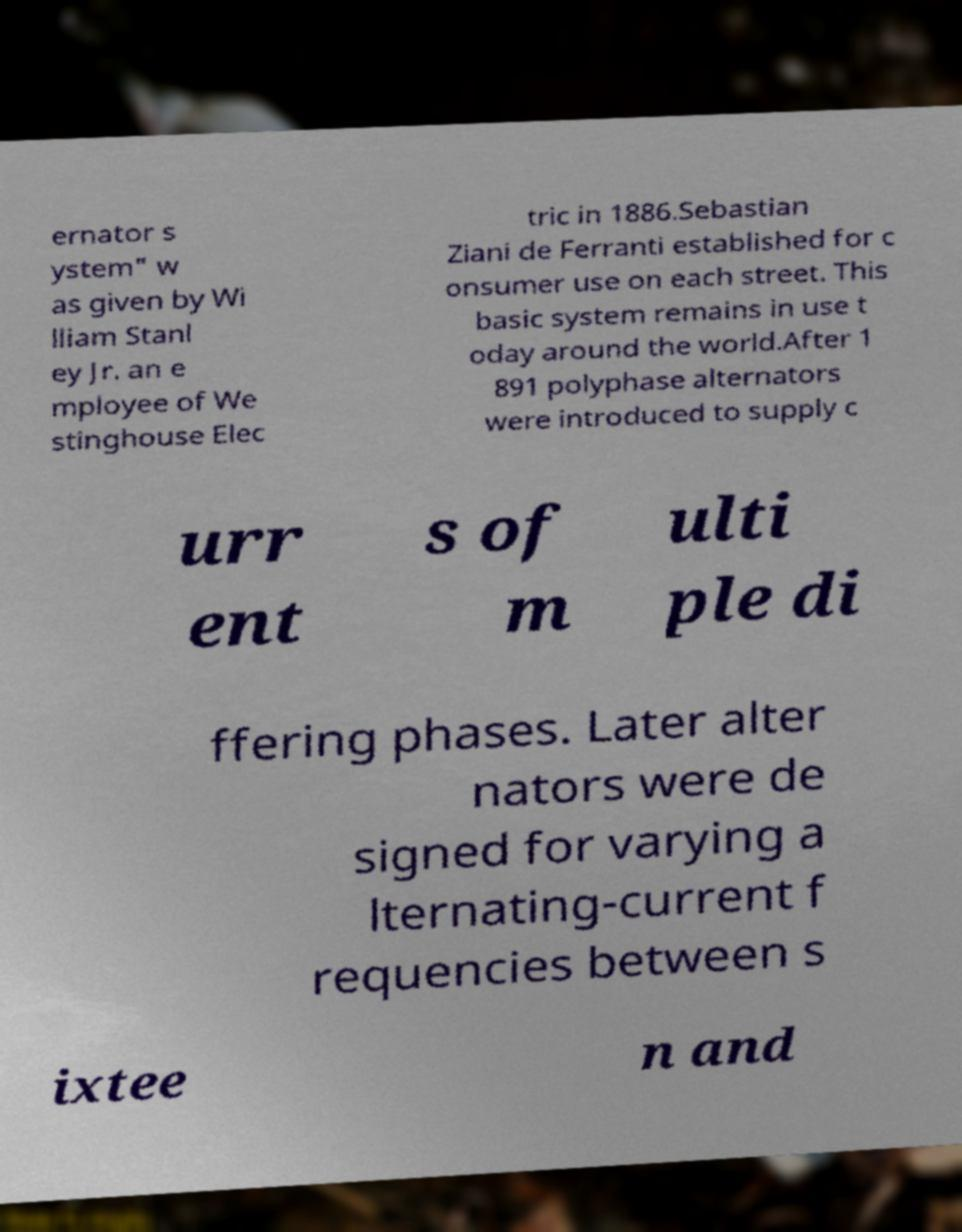Could you assist in decoding the text presented in this image and type it out clearly? ernator s ystem" w as given by Wi lliam Stanl ey Jr. an e mployee of We stinghouse Elec tric in 1886.Sebastian Ziani de Ferranti established for c onsumer use on each street. This basic system remains in use t oday around the world.After 1 891 polyphase alternators were introduced to supply c urr ent s of m ulti ple di ffering phases. Later alter nators were de signed for varying a lternating-current f requencies between s ixtee n and 